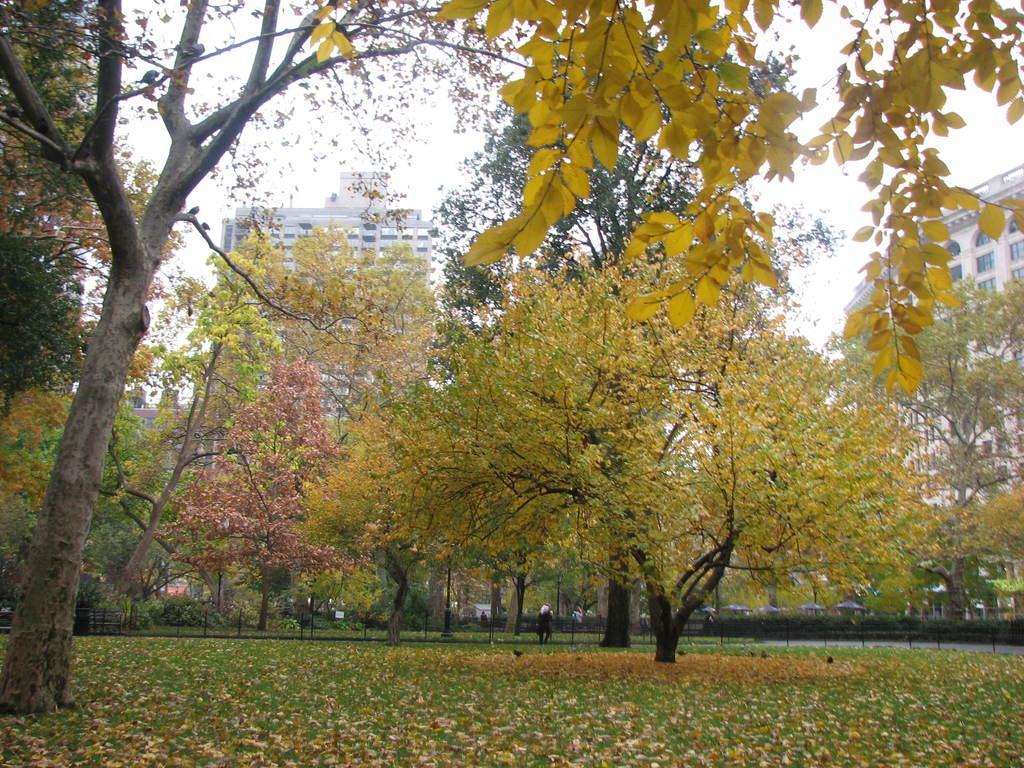Could you give a brief overview of what you see in this image? In this image, we can see so many trees, poles, grass and dry leaves. Background we can see buildings and sky. Here we can see a person. 